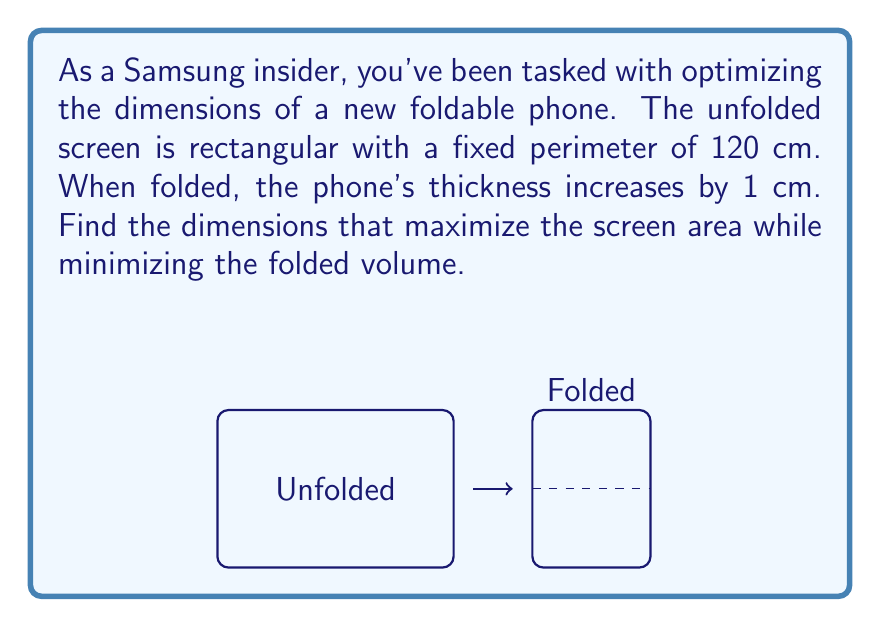What is the answer to this math problem? Let's approach this step-by-step:

1) Let the width of the unfolded phone be $x$ cm and the length be $y$ cm.

2) Given the fixed perimeter of 120 cm, we can write:
   $$2x + 2y = 120$$
   $$y = 60 - x$$

3) The area of the unfolded screen is:
   $$A = xy = x(60-x) = 60x - x^2$$

4) To find the maximum area, we differentiate A with respect to x and set it to zero:
   $$\frac{dA}{dx} = 60 - 2x = 0$$
   $$x = 30$$

5) This gives us the dimensions of the unfolded phone:
   Width (x) = 30 cm, Length (y) = 30 cm

6) When folded, the phone's dimensions become:
   Width = 15 cm (half of 30)
   Length = 30 cm
   Thickness = 1 cm (given that it increases by 1 cm when folded)

7) The folded volume is thus:
   $$V = 15 \times 30 \times 1 = 450 \text{ cm}^3$$

8) We can verify this is indeed the minimum volume by considering slightly different dimensions and calculating the resulting volumes.
Answer: Unfolded: 30 cm × 30 cm; Folded: 15 cm × 30 cm × 1 cm 